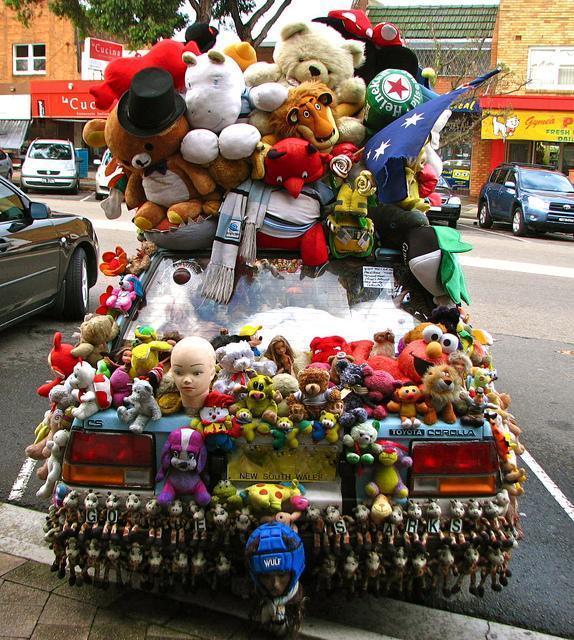How many cars can be seen?
Give a very brief answer. 4. How many teddy bears are there?
Give a very brief answer. 4. How many people are standing in front of the horse?
Give a very brief answer. 0. 